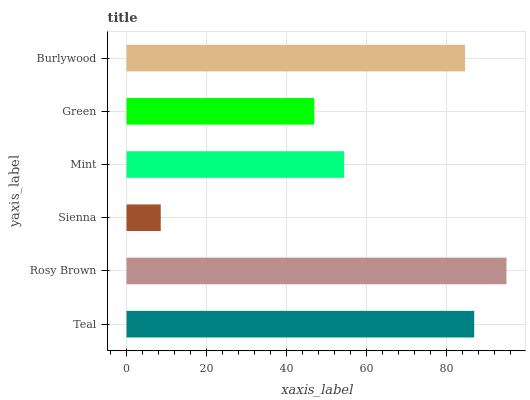Is Sienna the minimum?
Answer yes or no. Yes. Is Rosy Brown the maximum?
Answer yes or no. Yes. Is Rosy Brown the minimum?
Answer yes or no. No. Is Sienna the maximum?
Answer yes or no. No. Is Rosy Brown greater than Sienna?
Answer yes or no. Yes. Is Sienna less than Rosy Brown?
Answer yes or no. Yes. Is Sienna greater than Rosy Brown?
Answer yes or no. No. Is Rosy Brown less than Sienna?
Answer yes or no. No. Is Burlywood the high median?
Answer yes or no. Yes. Is Mint the low median?
Answer yes or no. Yes. Is Green the high median?
Answer yes or no. No. Is Teal the low median?
Answer yes or no. No. 